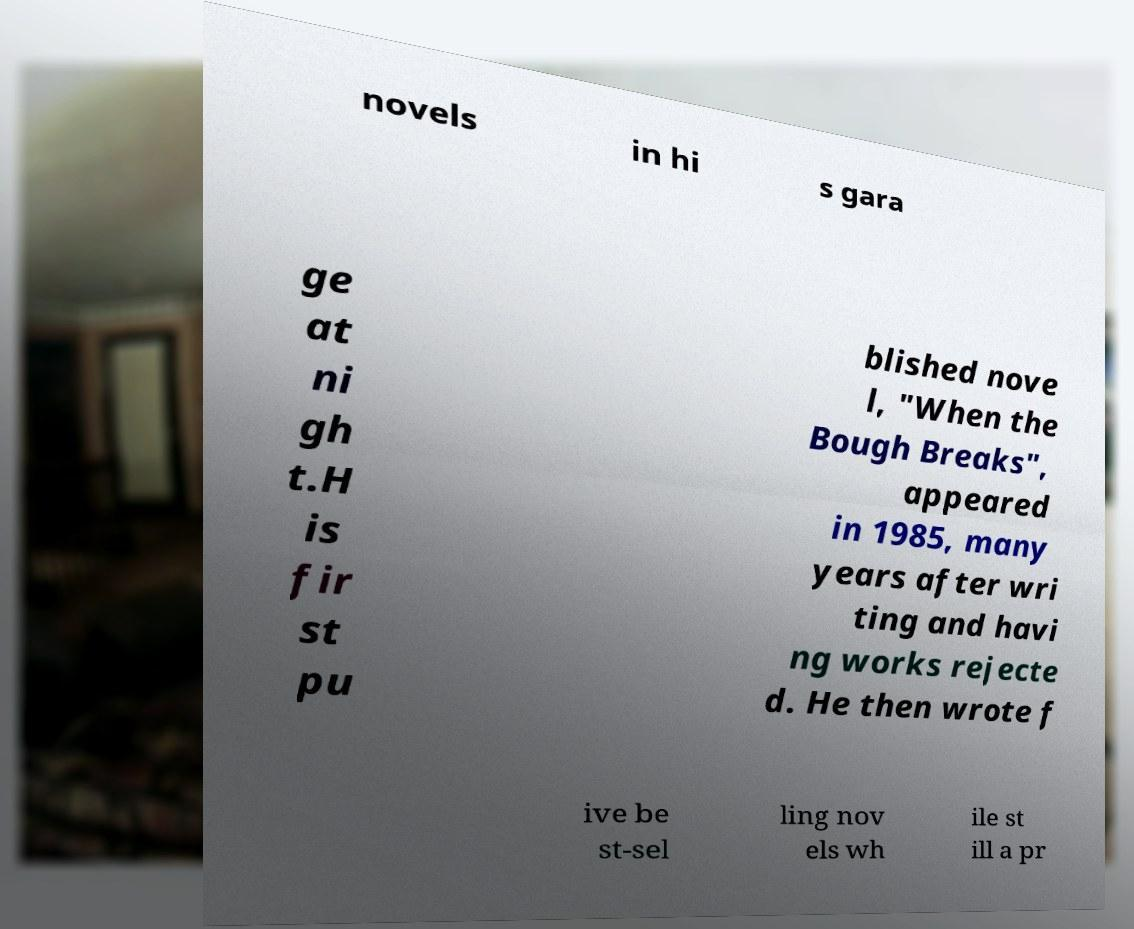Please identify and transcribe the text found in this image. novels in hi s gara ge at ni gh t.H is fir st pu blished nove l, "When the Bough Breaks", appeared in 1985, many years after wri ting and havi ng works rejecte d. He then wrote f ive be st-sel ling nov els wh ile st ill a pr 